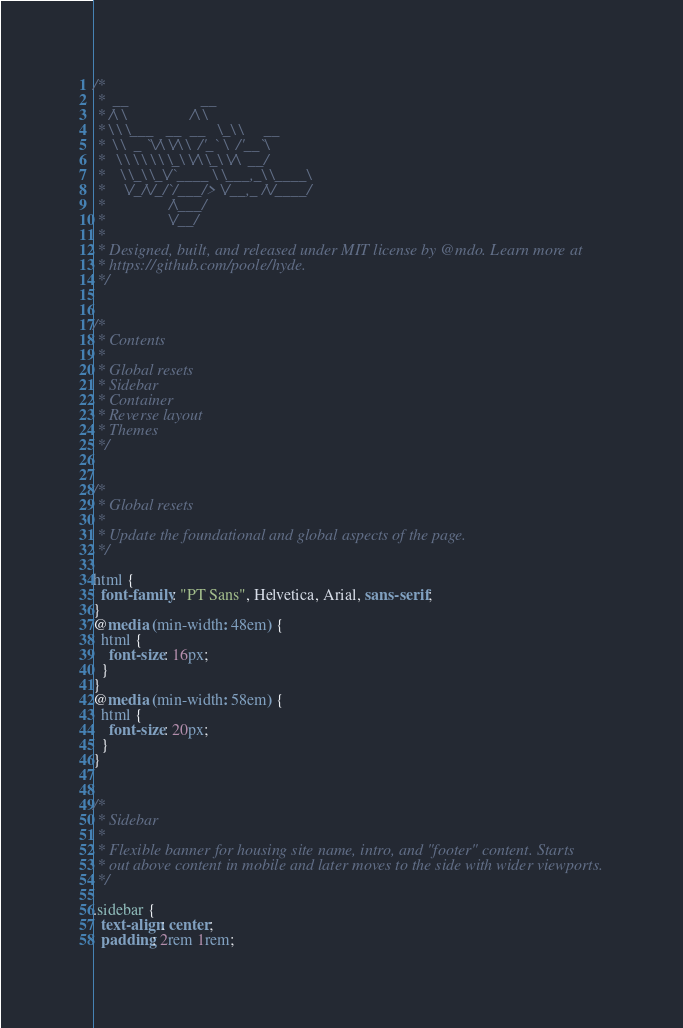<code> <loc_0><loc_0><loc_500><loc_500><_CSS_>/*
 *  __                  __
 * /\ \                /\ \
 * \ \ \___   __  __   \_\ \     __
 *  \ \  _ `\/\ \/\ \  /'_` \  /'__`\
 *   \ \ \ \ \ \ \_\ \/\ \_\ \/\  __/
 *    \ \_\ \_\/`____ \ \___,_\ \____\
 *     \/_/\/_/`/___/> \/__,_ /\/____/
 *                /\___/
 *                \/__/
 *
 * Designed, built, and released under MIT license by @mdo. Learn more at
 * https://github.com/poole/hyde.
 */


/*
 * Contents
 *
 * Global resets
 * Sidebar
 * Container
 * Reverse layout
 * Themes
 */


/*
 * Global resets
 *
 * Update the foundational and global aspects of the page.
 */

html {
  font-family: "PT Sans", Helvetica, Arial, sans-serif;
}
@media (min-width: 48em) {
  html {
    font-size: 16px;
  }
}
@media (min-width: 58em) {
  html {
    font-size: 20px;
  }
}


/*
 * Sidebar
 *
 * Flexible banner for housing site name, intro, and "footer" content. Starts
 * out above content in mobile and later moves to the side with wider viewports.
 */

.sidebar {
  text-align: center;
  padding: 2rem 1rem;</code> 